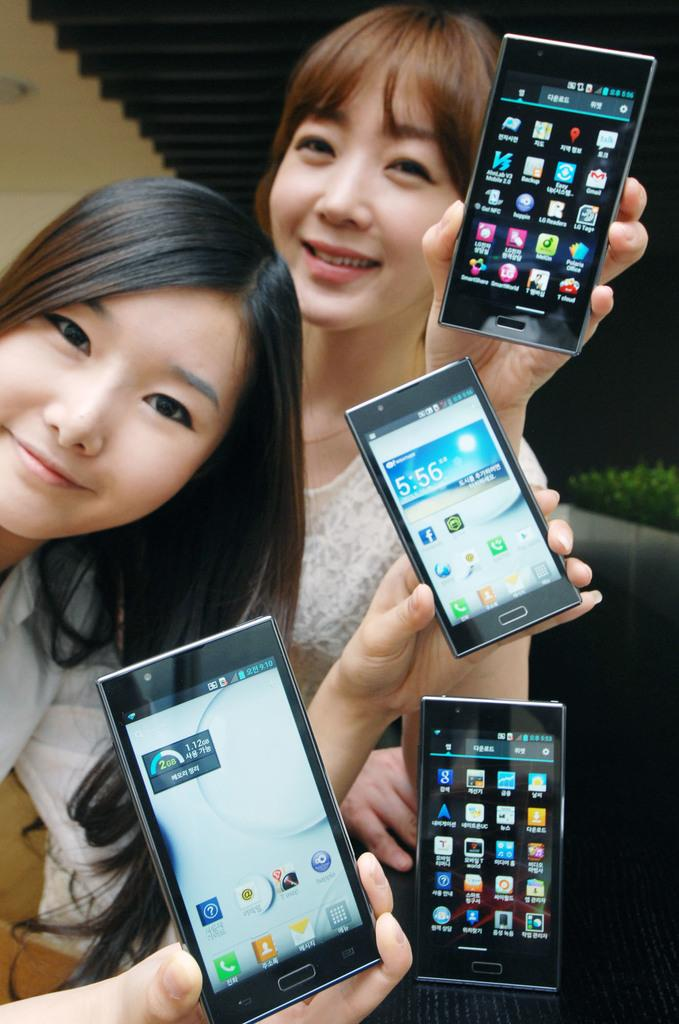How many people are in the image? There are people in the image, but the exact number is not specified. What are the people holding in the image? The people are holding mobile phones in the image. Can you see a rat building a nest in the image? There is no mention of a rat or a nest in the image, so we cannot confirm their presence. 